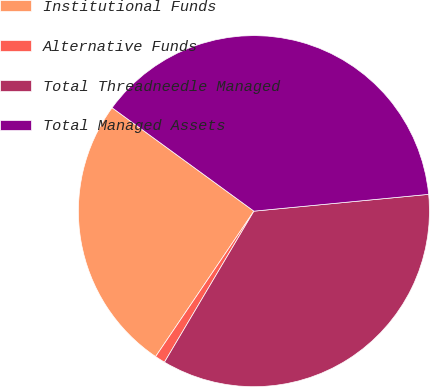Convert chart to OTSL. <chart><loc_0><loc_0><loc_500><loc_500><pie_chart><fcel>Institutional Funds<fcel>Alternative Funds<fcel>Total Threadneedle Managed<fcel>Total Managed Assets<nl><fcel>25.57%<fcel>0.95%<fcel>35.04%<fcel>38.45%<nl></chart> 